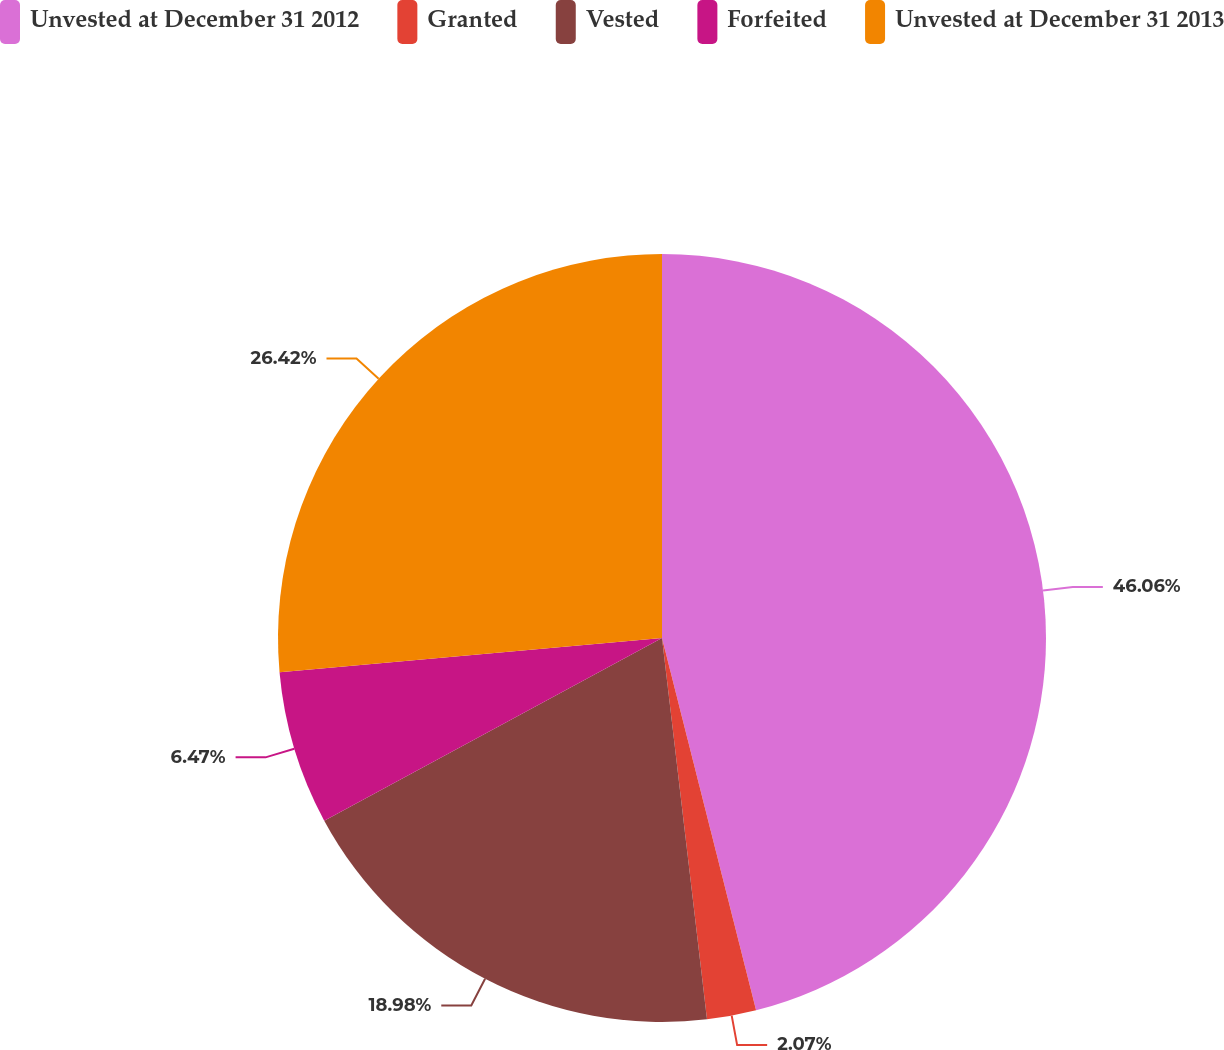Convert chart. <chart><loc_0><loc_0><loc_500><loc_500><pie_chart><fcel>Unvested at December 31 2012<fcel>Granted<fcel>Vested<fcel>Forfeited<fcel>Unvested at December 31 2013<nl><fcel>46.06%<fcel>2.07%<fcel>18.98%<fcel>6.47%<fcel>26.42%<nl></chart> 